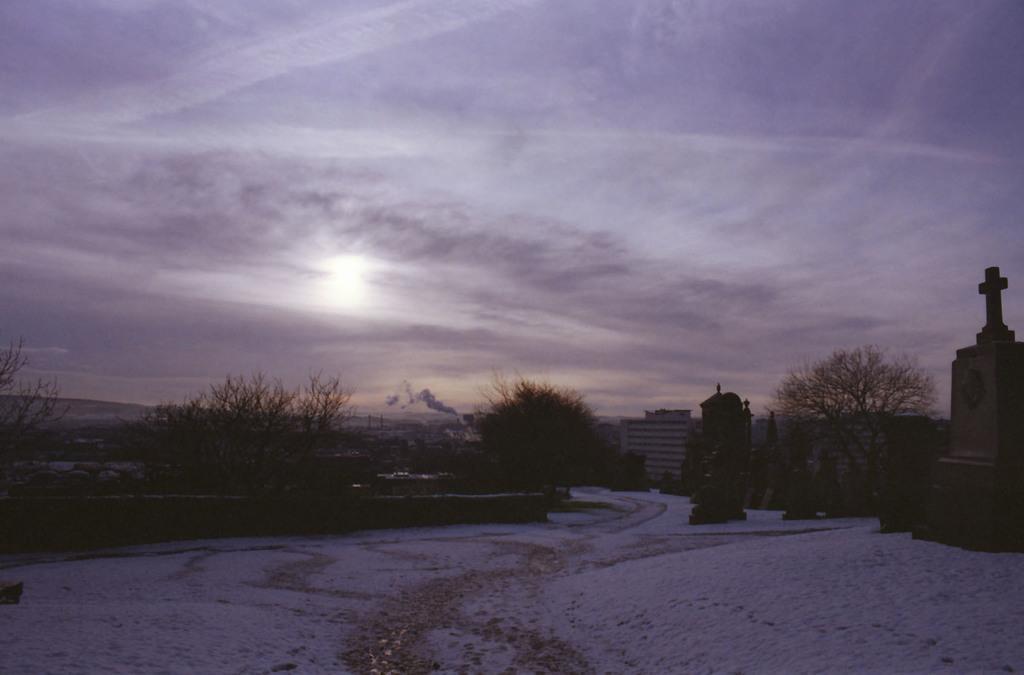Describe this image in one or two sentences. In the center of the image we can see the smoke. On the right side of the image we can see a statue. In the background of the image we can see the hills, trees, buildings. At the bottom of the image we can see the snow. At the top of the image we can see the clouds in the sky. 